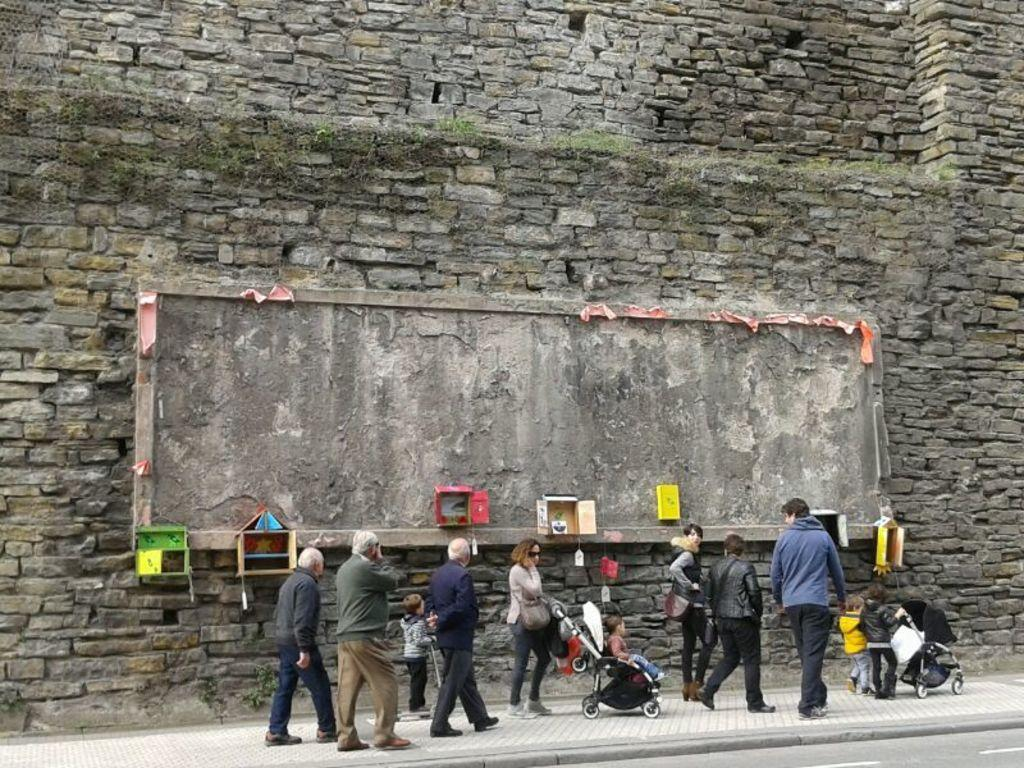How many people are in the image? There is a group of persons in the image. What are the persons in the image doing? The persons are walking on a sidewalk. What can be seen in the background of the image? There is a stone wall in the background of the image. Can you see a giraffe walking alongside the group of persons in the image? No, there is no giraffe present in the image. 